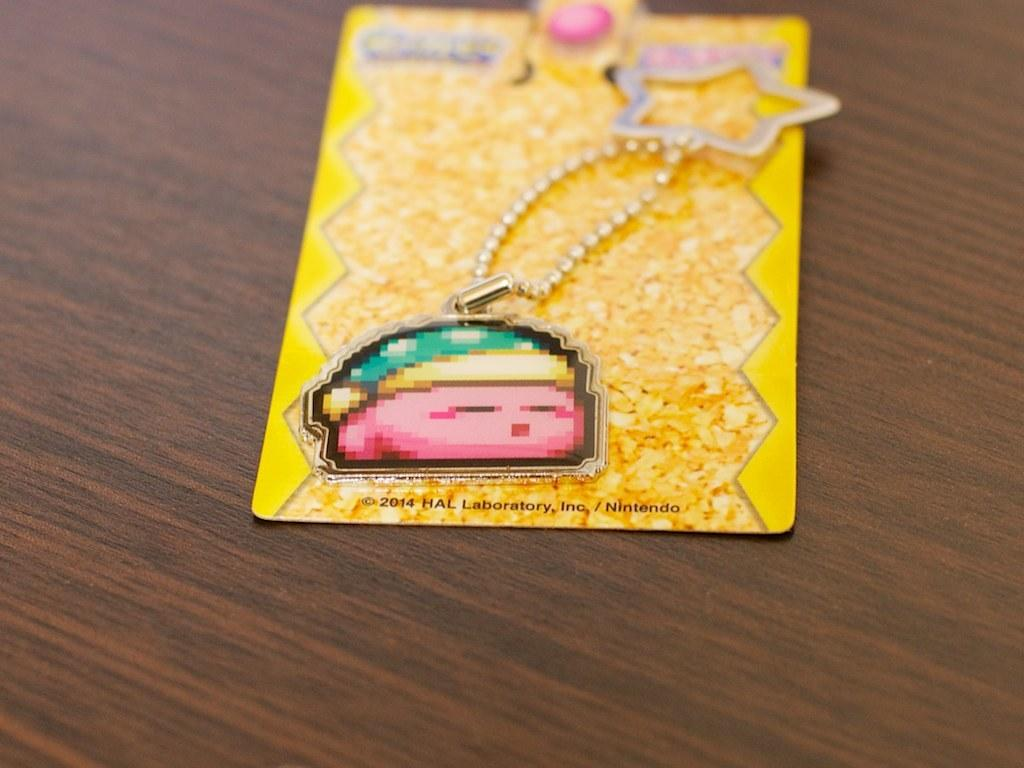What object is the main subject of the image? There is a car key chain in the image. Where is the key chain located? The key chain is on a table. How is the key chain being stored or protected? The key chain is packed in a cover. What color is the girl's hair in the image? There is no girl present in the image; it features a car key chain packed in a cover on a table. 